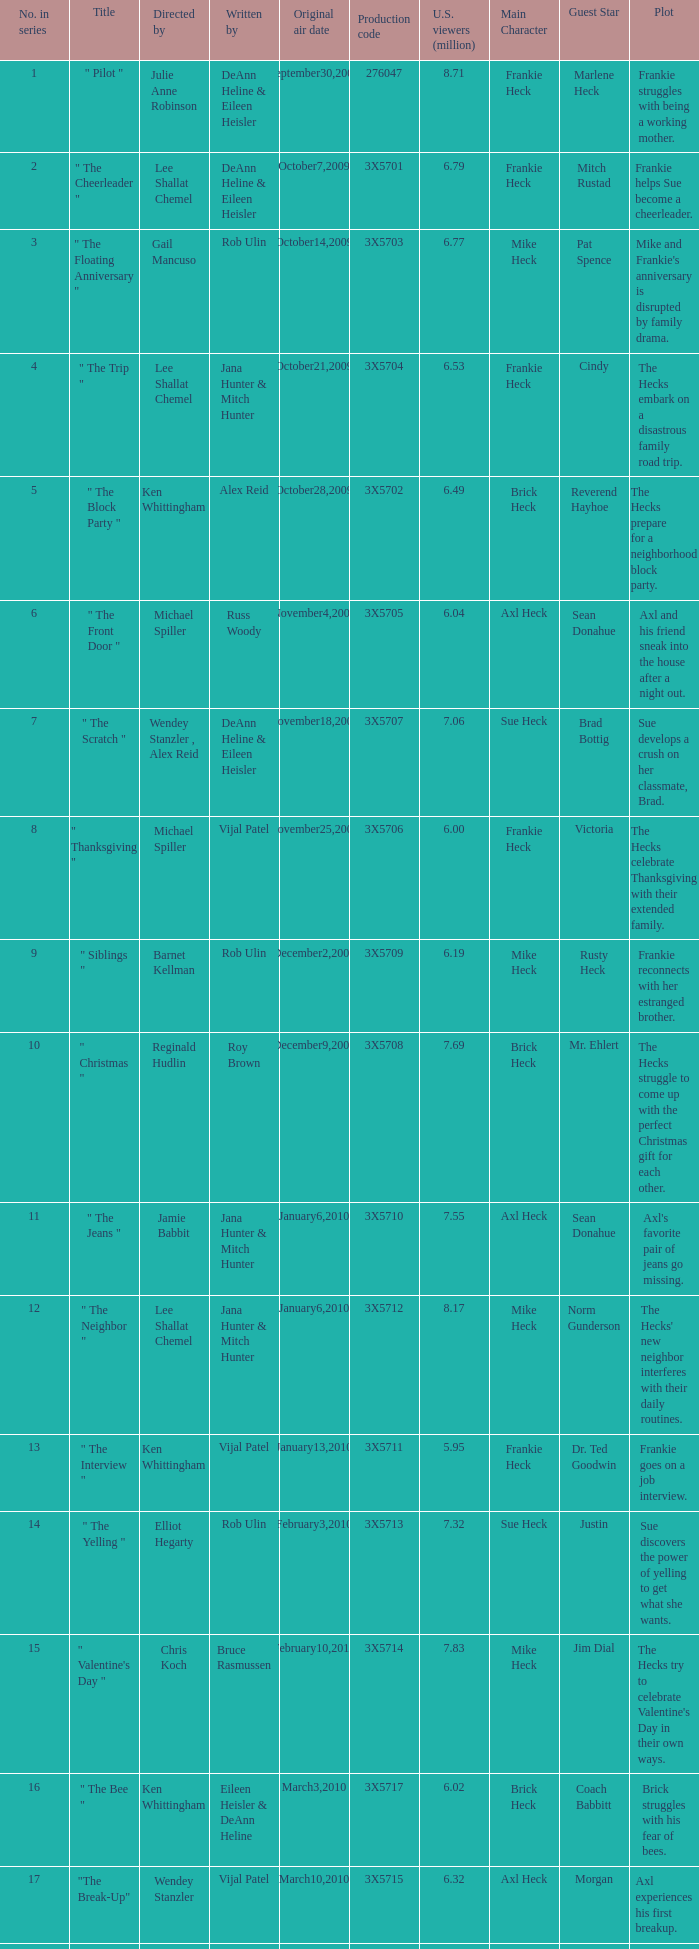How many directors got 6.79 million U.S. viewers from their episodes? 1.0. 